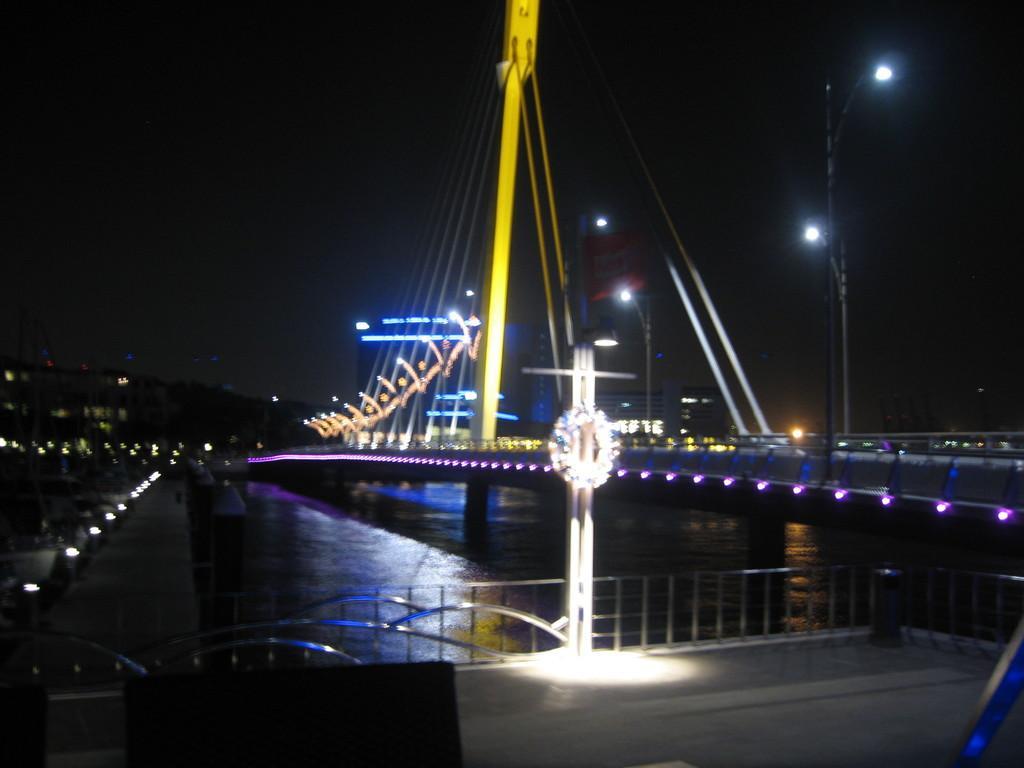In one or two sentences, can you explain what this image depicts? In this image we can see a bridge and water under the bridge and there is a railing and street lights on the bridge. 